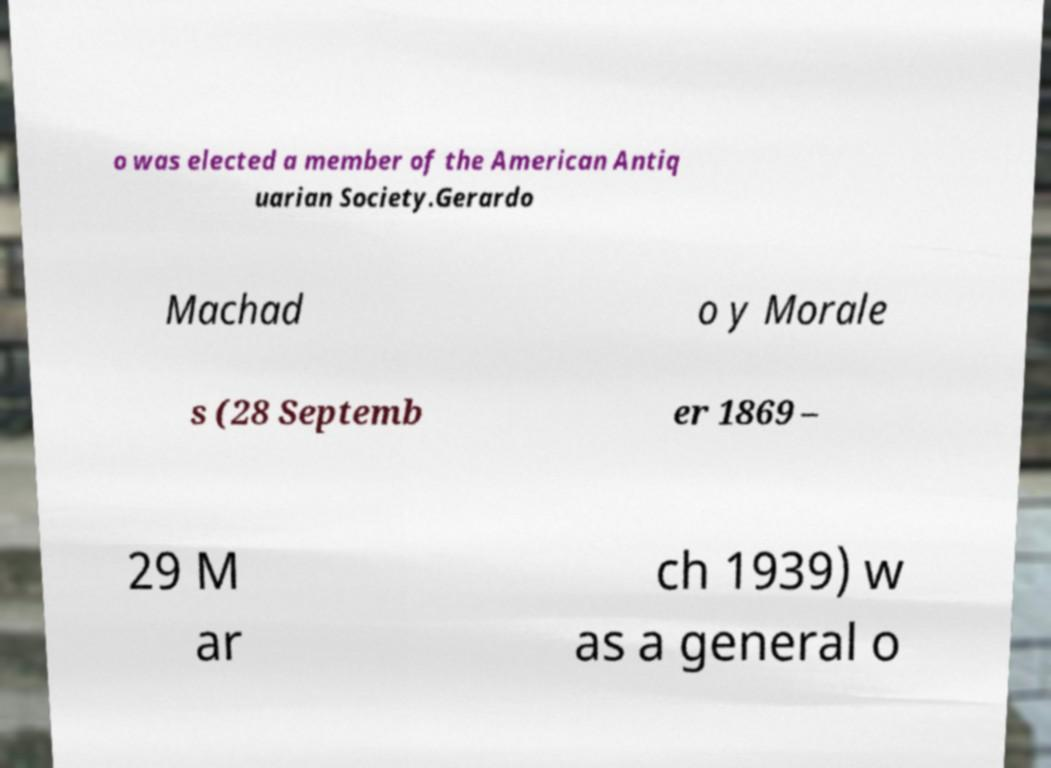Can you accurately transcribe the text from the provided image for me? o was elected a member of the American Antiq uarian Society.Gerardo Machad o y Morale s (28 Septemb er 1869 – 29 M ar ch 1939) w as a general o 